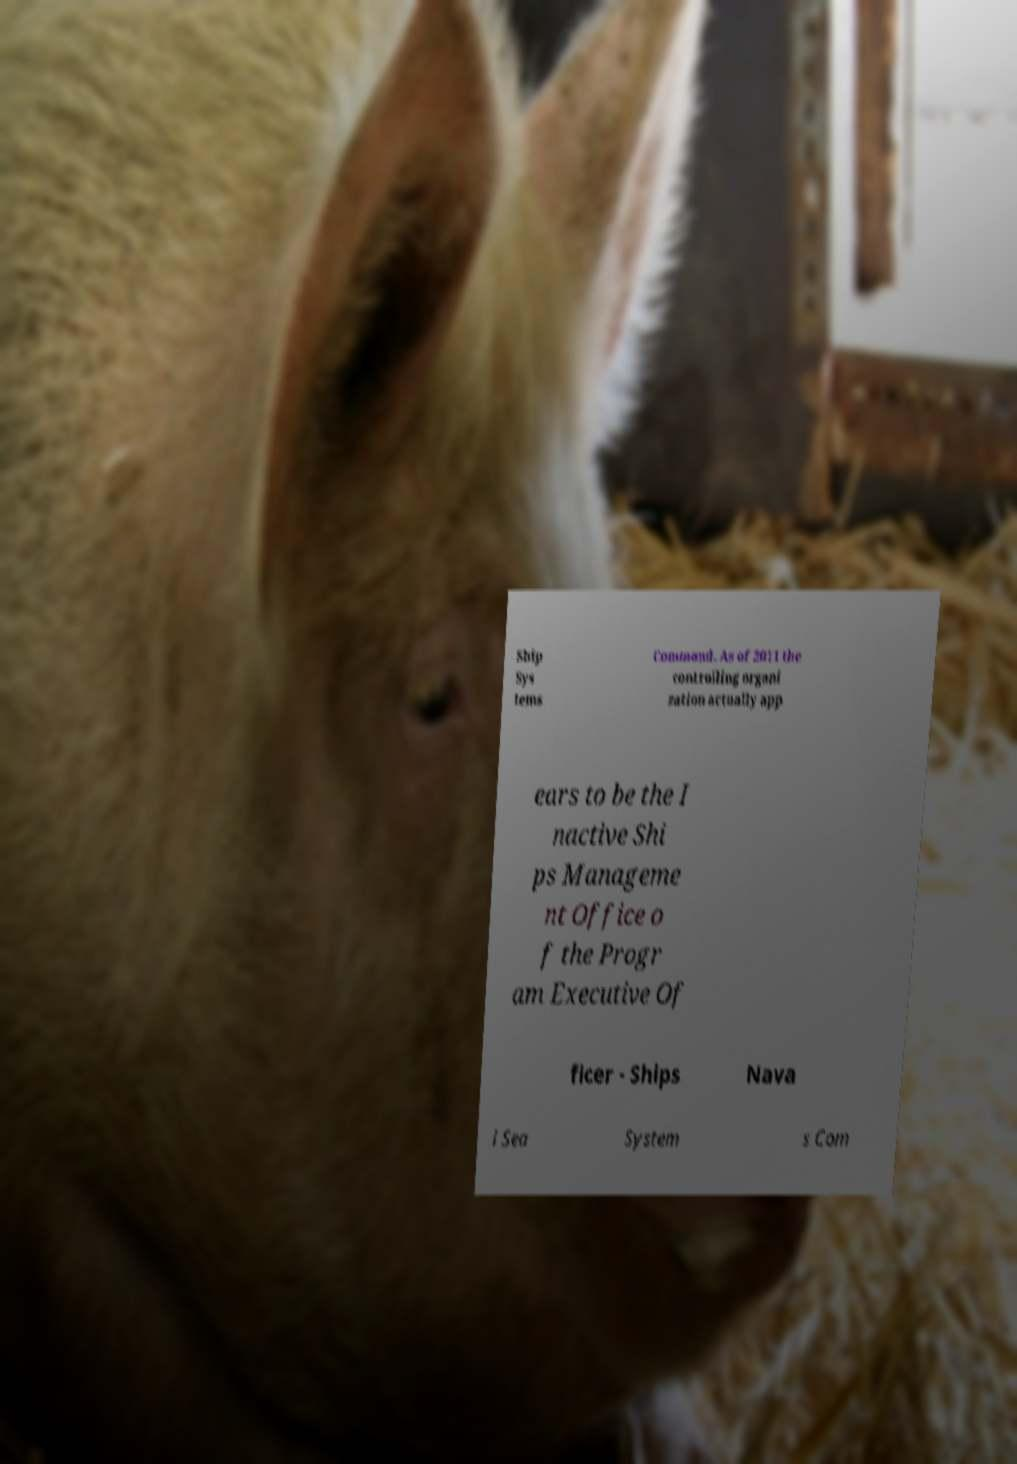Could you extract and type out the text from this image? Ship Sys tems Command. As of 2011 the controlling organi zation actually app ears to be the I nactive Shi ps Manageme nt Office o f the Progr am Executive Of ficer - Ships Nava l Sea System s Com 